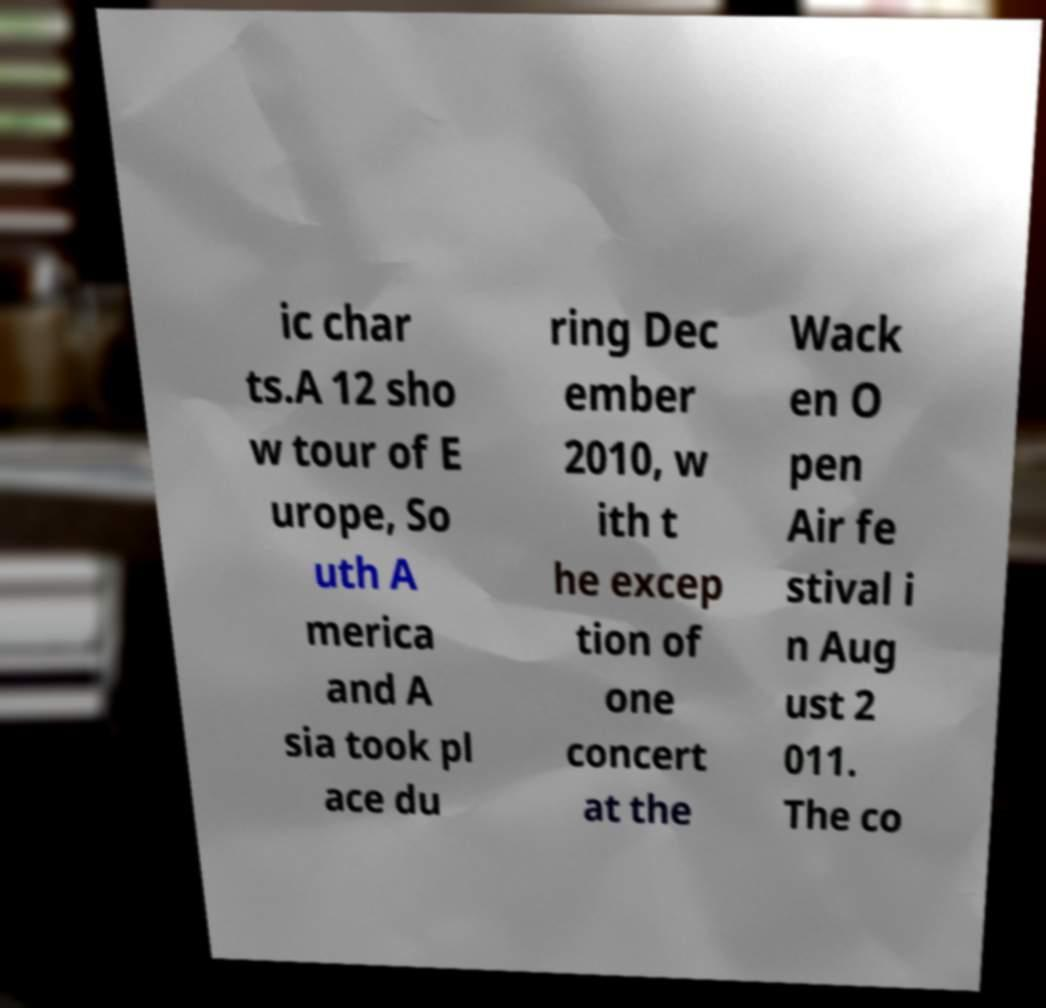There's text embedded in this image that I need extracted. Can you transcribe it verbatim? ic char ts.A 12 sho w tour of E urope, So uth A merica and A sia took pl ace du ring Dec ember 2010, w ith t he excep tion of one concert at the Wack en O pen Air fe stival i n Aug ust 2 011. The co 